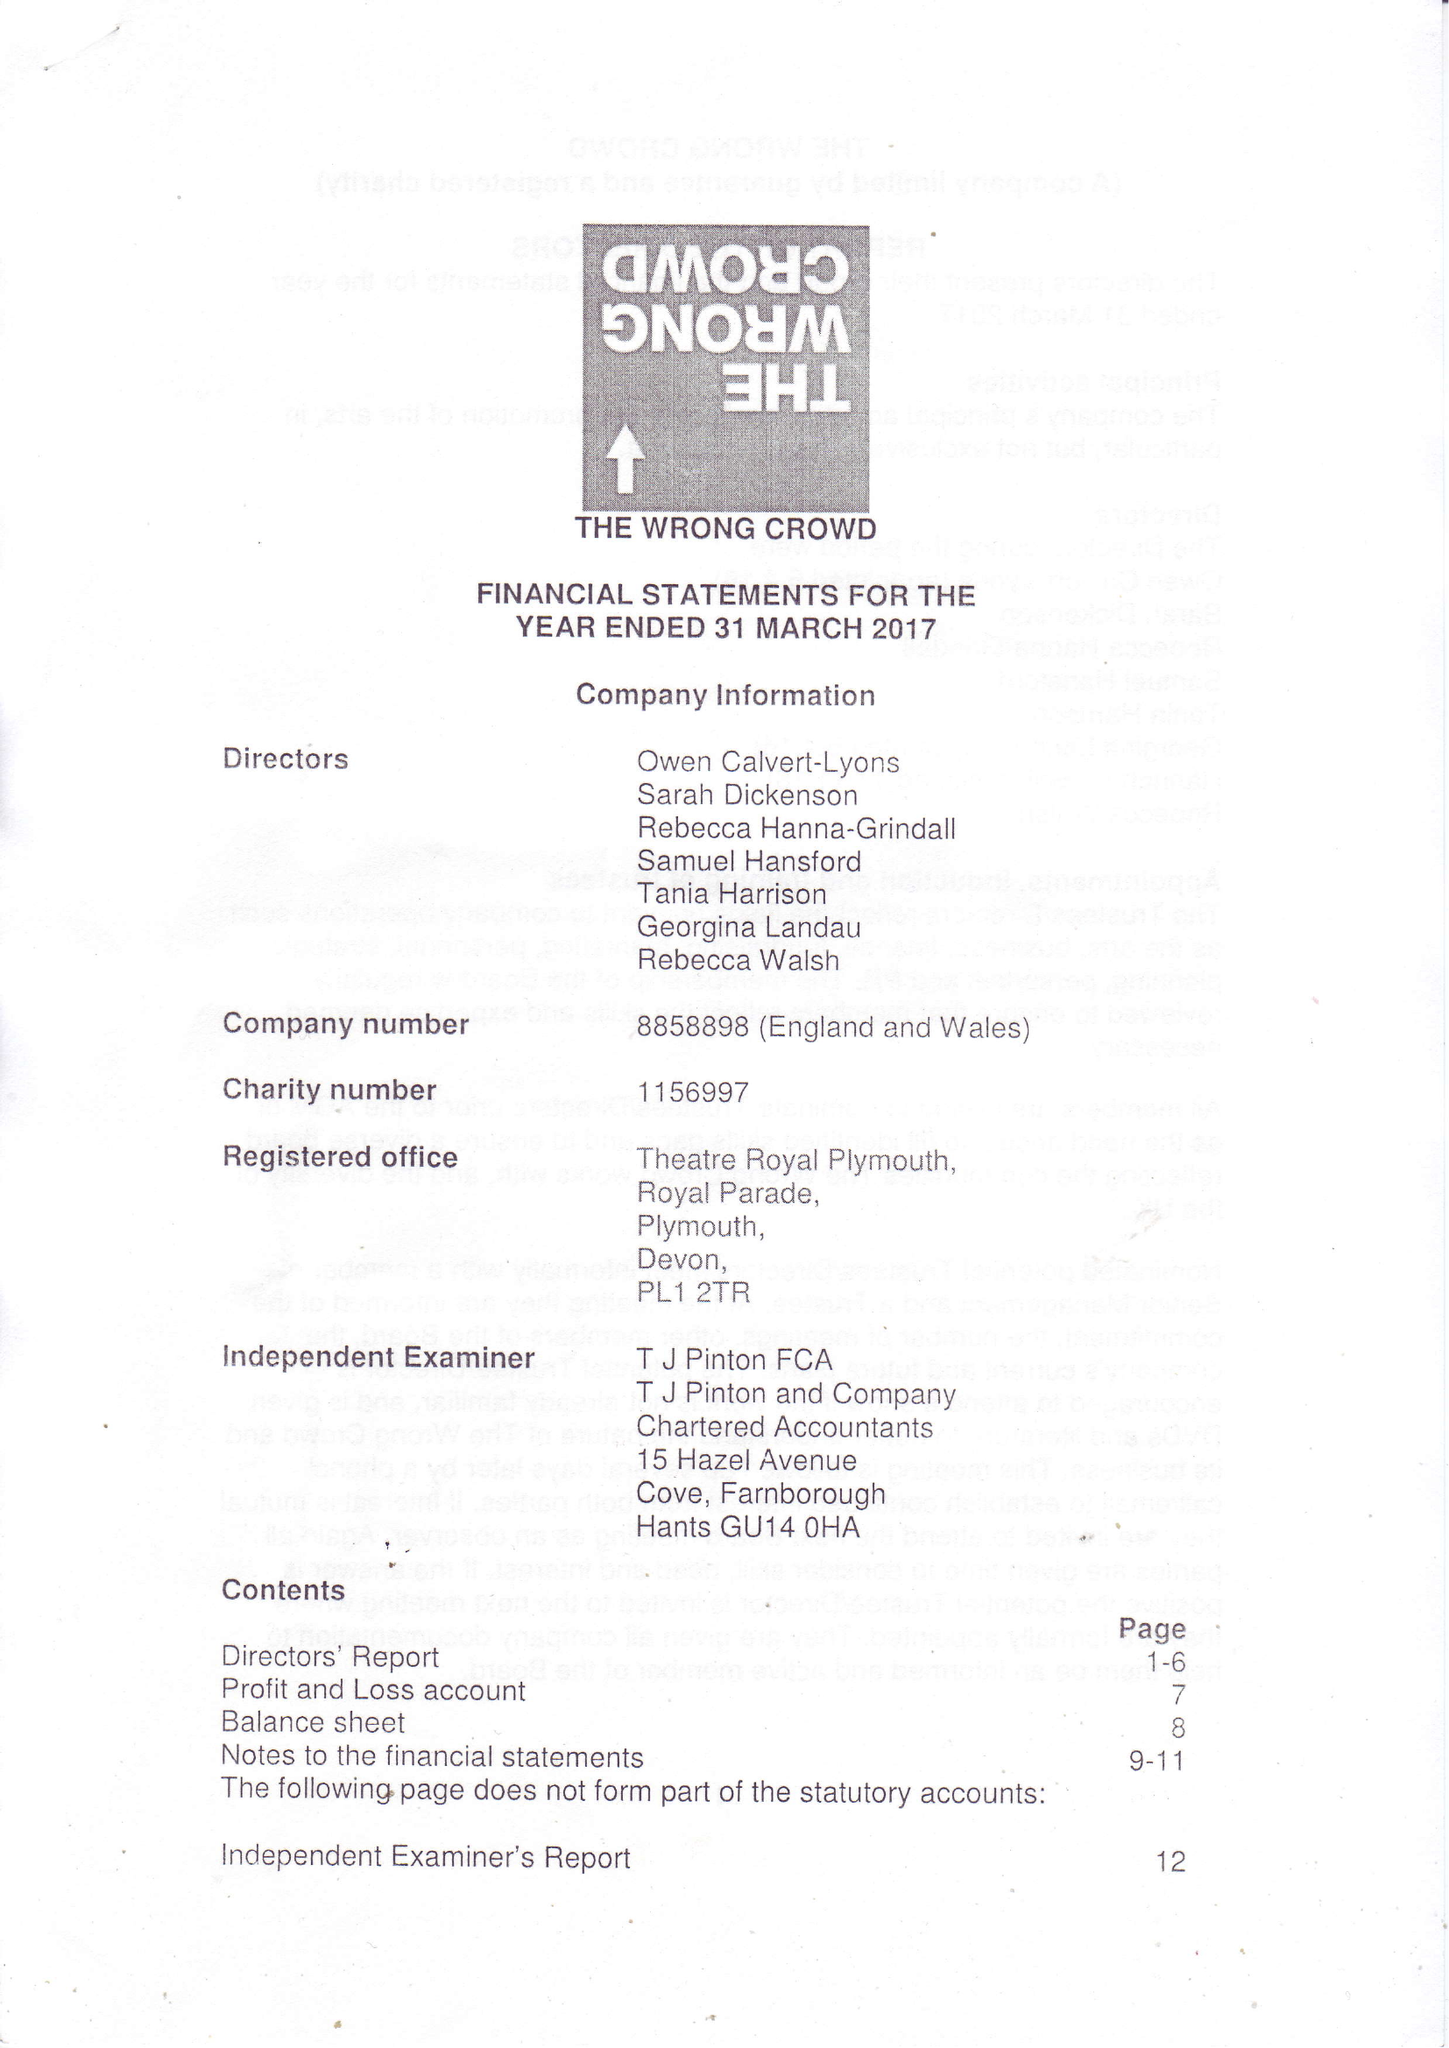What is the value for the report_date?
Answer the question using a single word or phrase. 2017-03-31 